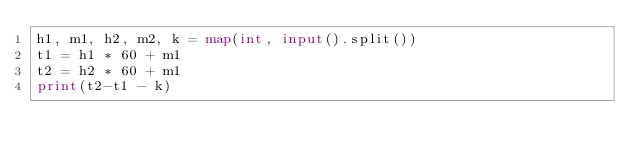<code> <loc_0><loc_0><loc_500><loc_500><_Python_>h1, m1, h2, m2, k = map(int, input().split())
t1 = h1 * 60 + m1
t2 = h2 * 60 + m1
print(t2-t1 - k)
</code> 